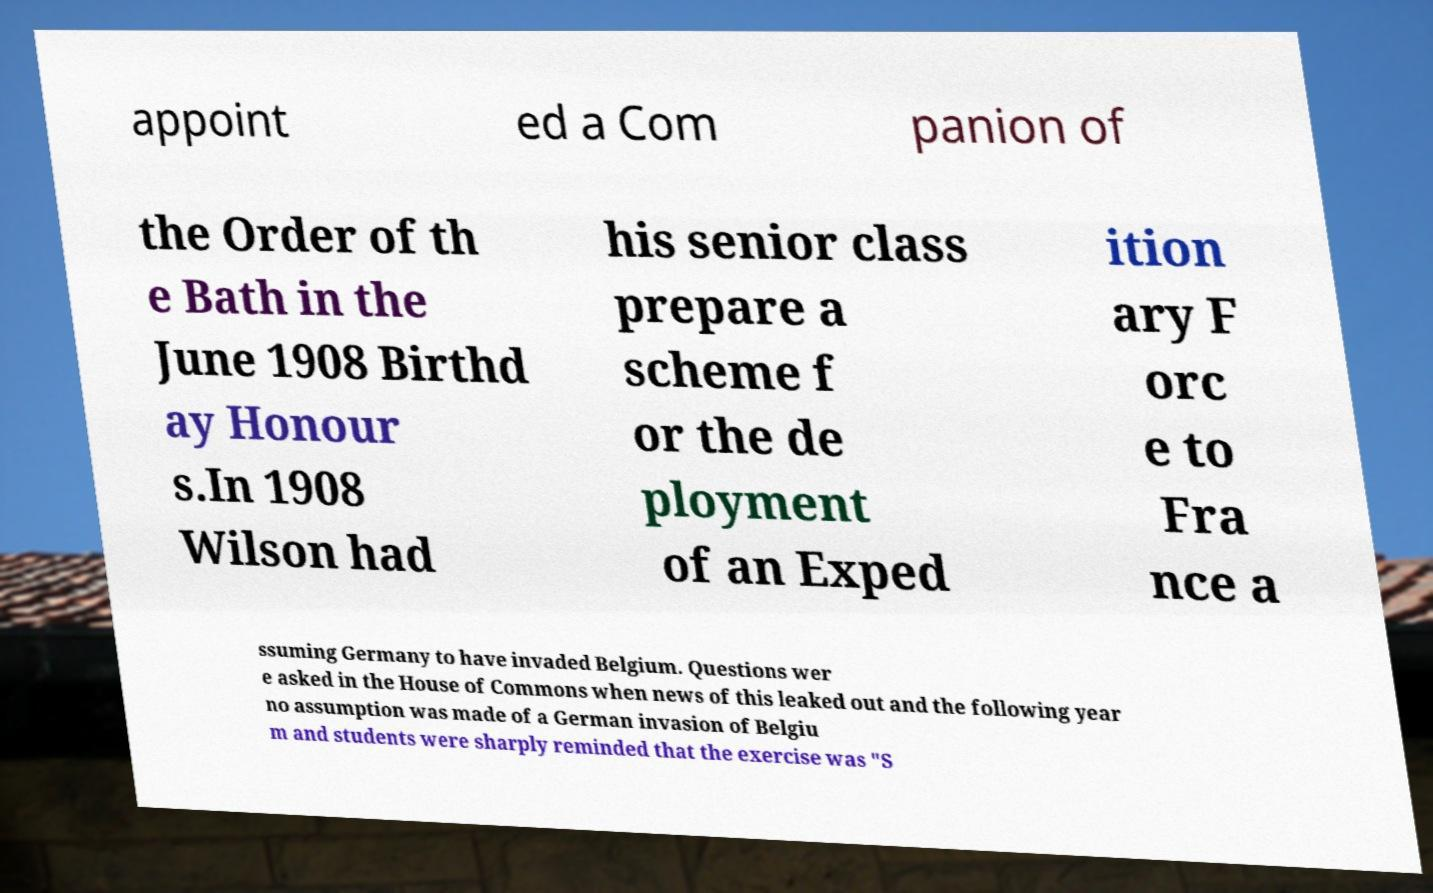I need the written content from this picture converted into text. Can you do that? appoint ed a Com panion of the Order of th e Bath in the June 1908 Birthd ay Honour s.In 1908 Wilson had his senior class prepare a scheme f or the de ployment of an Exped ition ary F orc e to Fra nce a ssuming Germany to have invaded Belgium. Questions wer e asked in the House of Commons when news of this leaked out and the following year no assumption was made of a German invasion of Belgiu m and students were sharply reminded that the exercise was "S 